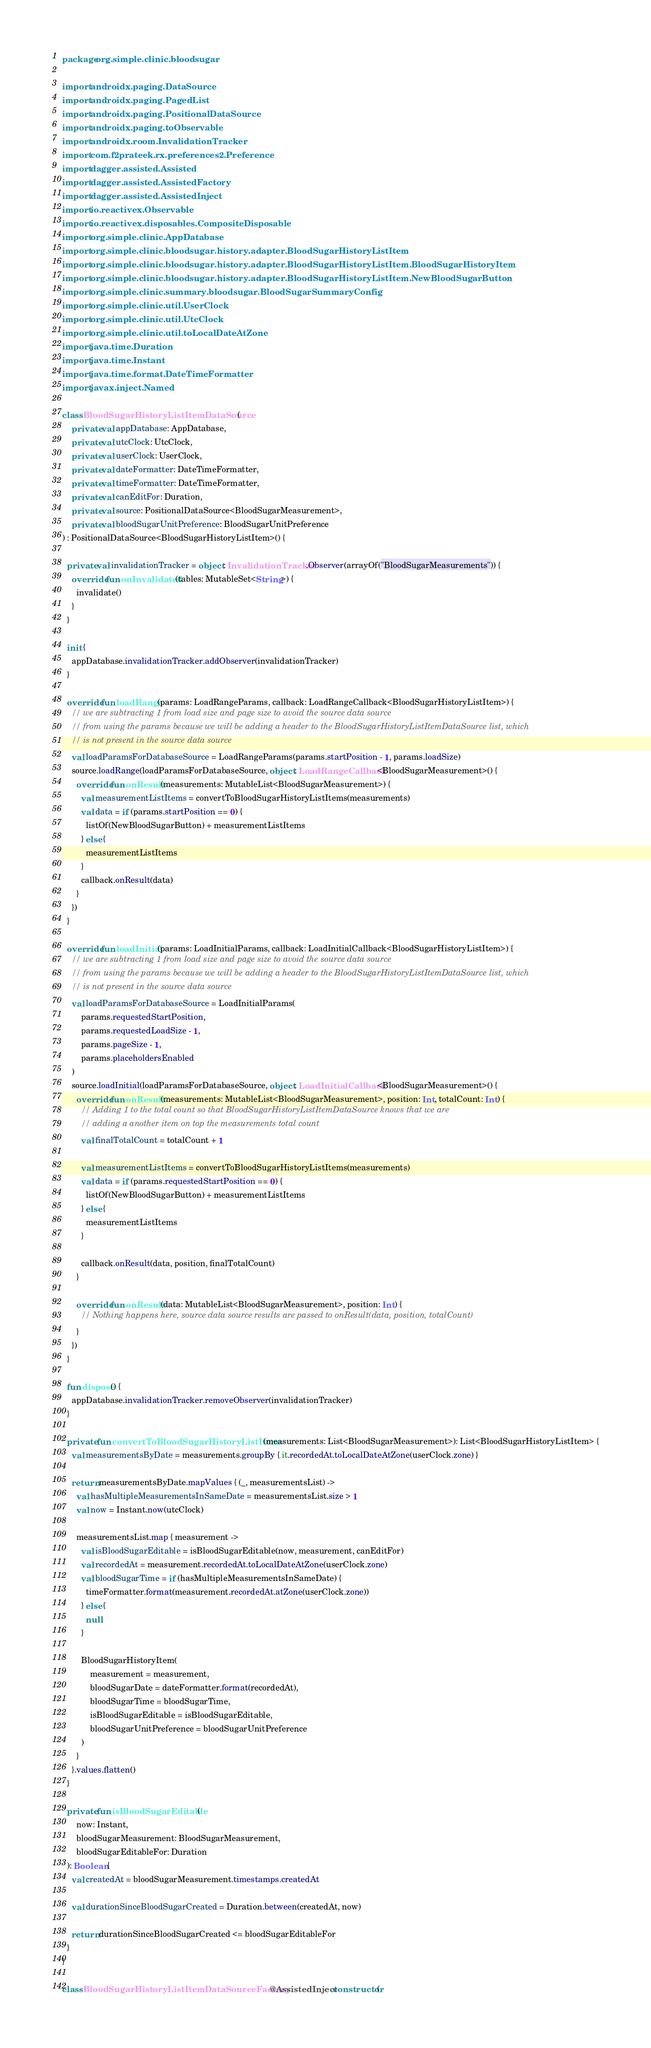<code> <loc_0><loc_0><loc_500><loc_500><_Kotlin_>package org.simple.clinic.bloodsugar

import androidx.paging.DataSource
import androidx.paging.PagedList
import androidx.paging.PositionalDataSource
import androidx.paging.toObservable
import androidx.room.InvalidationTracker
import com.f2prateek.rx.preferences2.Preference
import dagger.assisted.Assisted
import dagger.assisted.AssistedFactory
import dagger.assisted.AssistedInject
import io.reactivex.Observable
import io.reactivex.disposables.CompositeDisposable
import org.simple.clinic.AppDatabase
import org.simple.clinic.bloodsugar.history.adapter.BloodSugarHistoryListItem
import org.simple.clinic.bloodsugar.history.adapter.BloodSugarHistoryListItem.BloodSugarHistoryItem
import org.simple.clinic.bloodsugar.history.adapter.BloodSugarHistoryListItem.NewBloodSugarButton
import org.simple.clinic.summary.bloodsugar.BloodSugarSummaryConfig
import org.simple.clinic.util.UserClock
import org.simple.clinic.util.UtcClock
import org.simple.clinic.util.toLocalDateAtZone
import java.time.Duration
import java.time.Instant
import java.time.format.DateTimeFormatter
import javax.inject.Named

class BloodSugarHistoryListItemDataSource(
    private val appDatabase: AppDatabase,
    private val utcClock: UtcClock,
    private val userClock: UserClock,
    private val dateFormatter: DateTimeFormatter,
    private val timeFormatter: DateTimeFormatter,
    private val canEditFor: Duration,
    private val source: PositionalDataSource<BloodSugarMeasurement>,
    private val bloodSugarUnitPreference: BloodSugarUnitPreference
) : PositionalDataSource<BloodSugarHistoryListItem>() {

  private val invalidationTracker = object : InvalidationTracker.Observer(arrayOf("BloodSugarMeasurements")) {
    override fun onInvalidated(tables: MutableSet<String>) {
      invalidate()
    }
  }

  init {
    appDatabase.invalidationTracker.addObserver(invalidationTracker)
  }

  override fun loadRange(params: LoadRangeParams, callback: LoadRangeCallback<BloodSugarHistoryListItem>) {
    // we are subtracting 1 from load size and page size to avoid the source data source
    // from using the params because we will be adding a header to the BloodSugarHistoryListItemDataSource list, which
    // is not present in the source data source
    val loadParamsForDatabaseSource = LoadRangeParams(params.startPosition - 1, params.loadSize)
    source.loadRange(loadParamsForDatabaseSource, object : LoadRangeCallback<BloodSugarMeasurement>() {
      override fun onResult(measurements: MutableList<BloodSugarMeasurement>) {
        val measurementListItems = convertToBloodSugarHistoryListItems(measurements)
        val data = if (params.startPosition == 0) {
          listOf(NewBloodSugarButton) + measurementListItems
        } else {
          measurementListItems
        }
        callback.onResult(data)
      }
    })
  }

  override fun loadInitial(params: LoadInitialParams, callback: LoadInitialCallback<BloodSugarHistoryListItem>) {
    // we are subtracting 1 from load size and page size to avoid the source data source
    // from using the params because we will be adding a header to the BloodSugarHistoryListItemDataSource list, which
    // is not present in the source data source
    val loadParamsForDatabaseSource = LoadInitialParams(
        params.requestedStartPosition,
        params.requestedLoadSize - 1,
        params.pageSize - 1,
        params.placeholdersEnabled
    )
    source.loadInitial(loadParamsForDatabaseSource, object : LoadInitialCallback<BloodSugarMeasurement>() {
      override fun onResult(measurements: MutableList<BloodSugarMeasurement>, position: Int, totalCount: Int) {
        // Adding 1 to the total count so that BloodSugarHistoryListItemDataSource knows that we are
        // adding a another item on top the measurements total count
        val finalTotalCount = totalCount + 1

        val measurementListItems = convertToBloodSugarHistoryListItems(measurements)
        val data = if (params.requestedStartPosition == 0) {
          listOf(NewBloodSugarButton) + measurementListItems
        } else {
          measurementListItems
        }

        callback.onResult(data, position, finalTotalCount)
      }

      override fun onResult(data: MutableList<BloodSugarMeasurement>, position: Int) {
        // Nothing happens here, source data source results are passed to onResult(data, position, totalCount)
      }
    })
  }

  fun dispose() {
    appDatabase.invalidationTracker.removeObserver(invalidationTracker)
  }

  private fun convertToBloodSugarHistoryListItems(measurements: List<BloodSugarMeasurement>): List<BloodSugarHistoryListItem> {
    val measurementsByDate = measurements.groupBy { it.recordedAt.toLocalDateAtZone(userClock.zone) }

    return measurementsByDate.mapValues { (_, measurementsList) ->
      val hasMultipleMeasurementsInSameDate = measurementsList.size > 1
      val now = Instant.now(utcClock)

      measurementsList.map { measurement ->
        val isBloodSugarEditable = isBloodSugarEditable(now, measurement, canEditFor)
        val recordedAt = measurement.recordedAt.toLocalDateAtZone(userClock.zone)
        val bloodSugarTime = if (hasMultipleMeasurementsInSameDate) {
          timeFormatter.format(measurement.recordedAt.atZone(userClock.zone))
        } else {
          null
        }

        BloodSugarHistoryItem(
            measurement = measurement,
            bloodSugarDate = dateFormatter.format(recordedAt),
            bloodSugarTime = bloodSugarTime,
            isBloodSugarEditable = isBloodSugarEditable,
            bloodSugarUnitPreference = bloodSugarUnitPreference
        )
      }
    }.values.flatten()
  }

  private fun isBloodSugarEditable(
      now: Instant,
      bloodSugarMeasurement: BloodSugarMeasurement,
      bloodSugarEditableFor: Duration
  ): Boolean {
    val createdAt = bloodSugarMeasurement.timestamps.createdAt

    val durationSinceBloodSugarCreated = Duration.between(createdAt, now)

    return durationSinceBloodSugarCreated <= bloodSugarEditableFor
  }
}

class BloodSugarHistoryListItemDataSourceFactory @AssistedInject constructor(</code> 